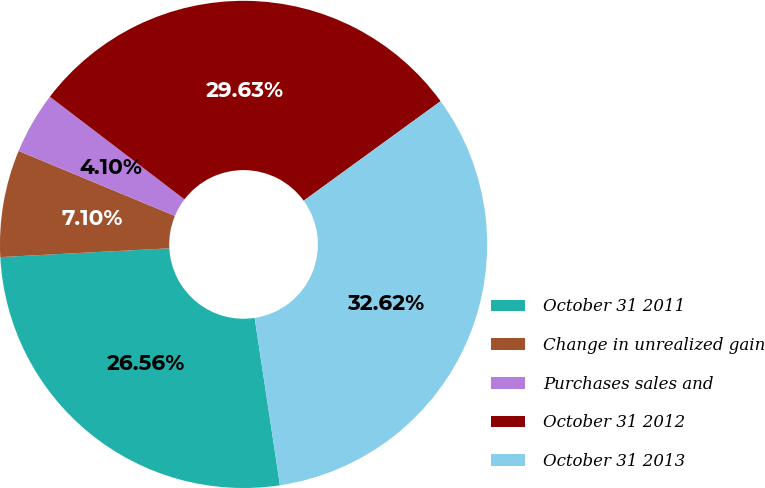<chart> <loc_0><loc_0><loc_500><loc_500><pie_chart><fcel>October 31 2011<fcel>Change in unrealized gain<fcel>Purchases sales and<fcel>October 31 2012<fcel>October 31 2013<nl><fcel>26.56%<fcel>7.1%<fcel>4.1%<fcel>29.63%<fcel>32.62%<nl></chart> 